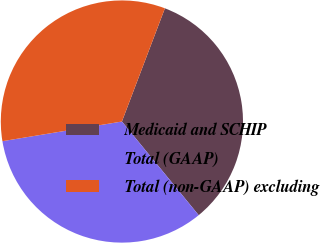Convert chart to OTSL. <chart><loc_0><loc_0><loc_500><loc_500><pie_chart><fcel>Medicaid and SCHIP<fcel>Total (GAAP)<fcel>Total (non-GAAP) excluding<nl><fcel>33.29%<fcel>33.33%<fcel>33.37%<nl></chart> 